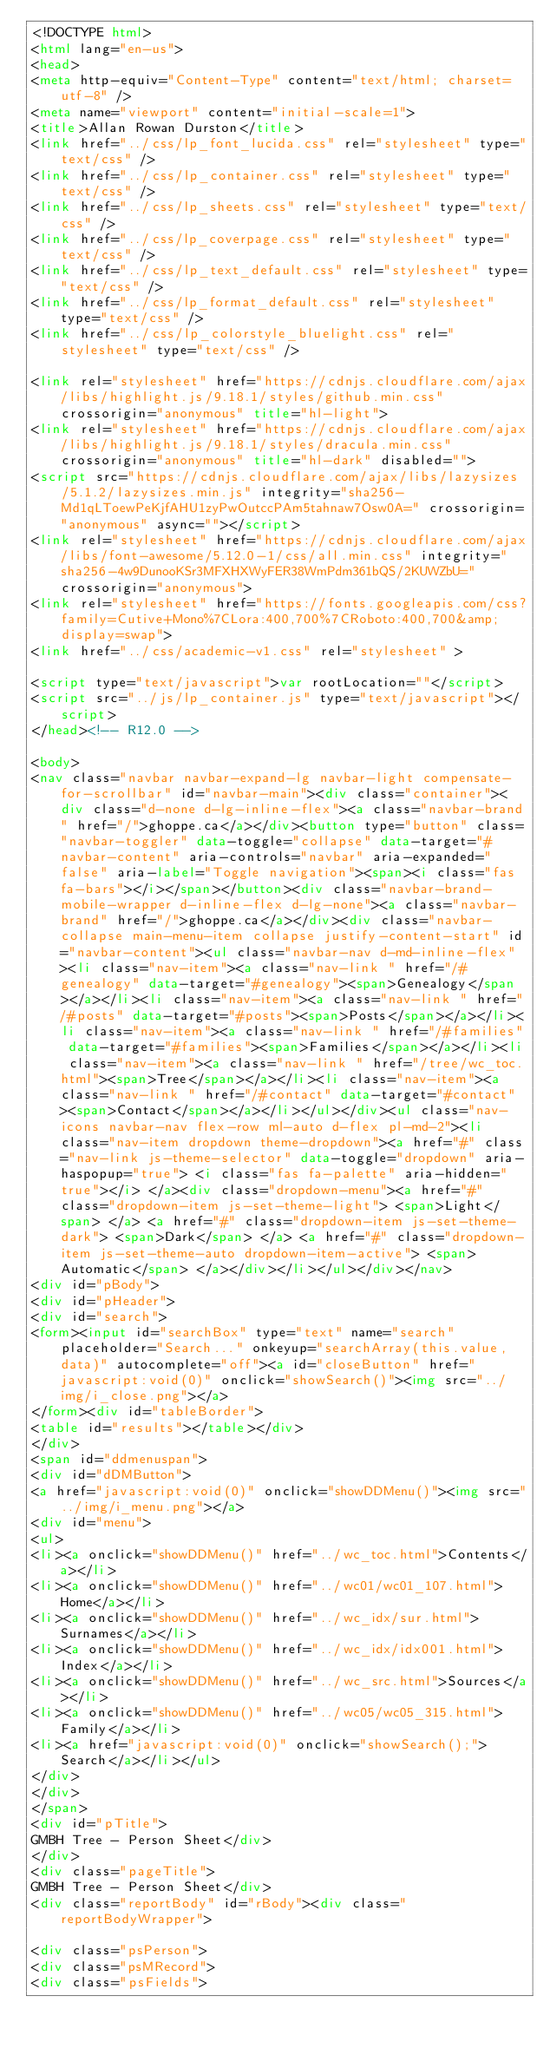Convert code to text. <code><loc_0><loc_0><loc_500><loc_500><_HTML_><!DOCTYPE html>
<html lang="en-us">
<head>
<meta http-equiv="Content-Type" content="text/html; charset=utf-8" />
<meta name="viewport" content="initial-scale=1">
<title>Allan Rowan Durston</title>
<link href="../css/lp_font_lucida.css" rel="stylesheet" type="text/css" />
<link href="../css/lp_container.css" rel="stylesheet" type="text/css" />
<link href="../css/lp_sheets.css" rel="stylesheet" type="text/css" />
<link href="../css/lp_coverpage.css" rel="stylesheet" type="text/css" />
<link href="../css/lp_text_default.css" rel="stylesheet" type="text/css" />
<link href="../css/lp_format_default.css" rel="stylesheet" type="text/css" />
<link href="../css/lp_colorstyle_bluelight.css" rel="stylesheet" type="text/css" />

<link rel="stylesheet" href="https://cdnjs.cloudflare.com/ajax/libs/highlight.js/9.18.1/styles/github.min.css" crossorigin="anonymous" title="hl-light">
<link rel="stylesheet" href="https://cdnjs.cloudflare.com/ajax/libs/highlight.js/9.18.1/styles/dracula.min.css" crossorigin="anonymous" title="hl-dark" disabled="">
<script src="https://cdnjs.cloudflare.com/ajax/libs/lazysizes/5.1.2/lazysizes.min.js" integrity="sha256-Md1qLToewPeKjfAHU1zyPwOutccPAm5tahnaw7Osw0A=" crossorigin="anonymous" async=""></script>
<link rel="stylesheet" href="https://cdnjs.cloudflare.com/ajax/libs/font-awesome/5.12.0-1/css/all.min.css" integrity="sha256-4w9DunooKSr3MFXHXWyFER38WmPdm361bQS/2KUWZbU=" crossorigin="anonymous">
<link rel="stylesheet" href="https://fonts.googleapis.com/css?family=Cutive+Mono%7CLora:400,700%7CRoboto:400,700&amp;display=swap">
<link href="../css/academic-v1.css" rel="stylesheet" >

<script type="text/javascript">var rootLocation=""</script>
<script src="../js/lp_container.js" type="text/javascript"></script>
</head><!-- R12.0 -->

<body>
<nav class="navbar navbar-expand-lg navbar-light compensate-for-scrollbar" id="navbar-main"><div class="container"><div class="d-none d-lg-inline-flex"><a class="navbar-brand" href="/">ghoppe.ca</a></div><button type="button" class="navbar-toggler" data-toggle="collapse" data-target="#navbar-content" aria-controls="navbar" aria-expanded="false" aria-label="Toggle navigation"><span><i class="fas fa-bars"></i></span></button><div class="navbar-brand-mobile-wrapper d-inline-flex d-lg-none"><a class="navbar-brand" href="/">ghoppe.ca</a></div><div class="navbar-collapse main-menu-item collapse justify-content-start" id="navbar-content"><ul class="navbar-nav d-md-inline-flex"><li class="nav-item"><a class="nav-link " href="/#genealogy" data-target="#genealogy"><span>Genealogy</span></a></li><li class="nav-item"><a class="nav-link " href="/#posts" data-target="#posts"><span>Posts</span></a></li><li class="nav-item"><a class="nav-link " href="/#families" data-target="#families"><span>Families</span></a></li><li class="nav-item"><a class="nav-link " href="/tree/wc_toc.html"><span>Tree</span></a></li><li class="nav-item"><a class="nav-link " href="/#contact" data-target="#contact"><span>Contact</span></a></li></ul></div><ul class="nav-icons navbar-nav flex-row ml-auto d-flex pl-md-2"><li class="nav-item dropdown theme-dropdown"><a href="#" class="nav-link js-theme-selector" data-toggle="dropdown" aria-haspopup="true"> <i class="fas fa-palette" aria-hidden="true"></i> </a><div class="dropdown-menu"><a href="#" class="dropdown-item js-set-theme-light"> <span>Light</span> </a> <a href="#" class="dropdown-item js-set-theme-dark"> <span>Dark</span> </a> <a href="#" class="dropdown-item js-set-theme-auto dropdown-item-active"> <span>Automatic</span> </a></div></li></ul></div></nav>
<div id="pBody">
<div id="pHeader">
<div id="search">
<form><input id="searchBox" type="text" name="search" placeholder="Search..." onkeyup="searchArray(this.value,data)" autocomplete="off"><a id="closeButton" href="javascript:void(0)" onclick="showSearch()"><img src="../img/i_close.png"></a>
</form><div id="tableBorder">
<table id="results"></table></div>
</div>
<span id="ddmenuspan">
<div id="dDMButton">
<a href="javascript:void(0)" onclick="showDDMenu()"><img src="../img/i_menu.png"></a>
<div id="menu">
<ul>
<li><a onclick="showDDMenu()" href="../wc_toc.html">Contents</a></li>
<li><a onclick="showDDMenu()" href="../wc01/wc01_107.html">Home</a></li>
<li><a onclick="showDDMenu()" href="../wc_idx/sur.html">Surnames</a></li>
<li><a onclick="showDDMenu()" href="../wc_idx/idx001.html">Index</a></li>
<li><a onclick="showDDMenu()" href="../wc_src.html">Sources</a></li>
<li><a onclick="showDDMenu()" href="../wc05/wc05_315.html">Family</a></li>
<li><a href="javascript:void(0)" onclick="showSearch();">Search</a></li></ul>
</div>
</div>
</span>
<div id="pTitle">
GMBH Tree - Person Sheet</div>
</div>
<div class="pageTitle">
GMBH Tree - Person Sheet</div>
<div class="reportBody" id="rBody"><div class="reportBodyWrapper">

<div class="psPerson">
<div class="psMRecord">
<div class="psFields"></code> 